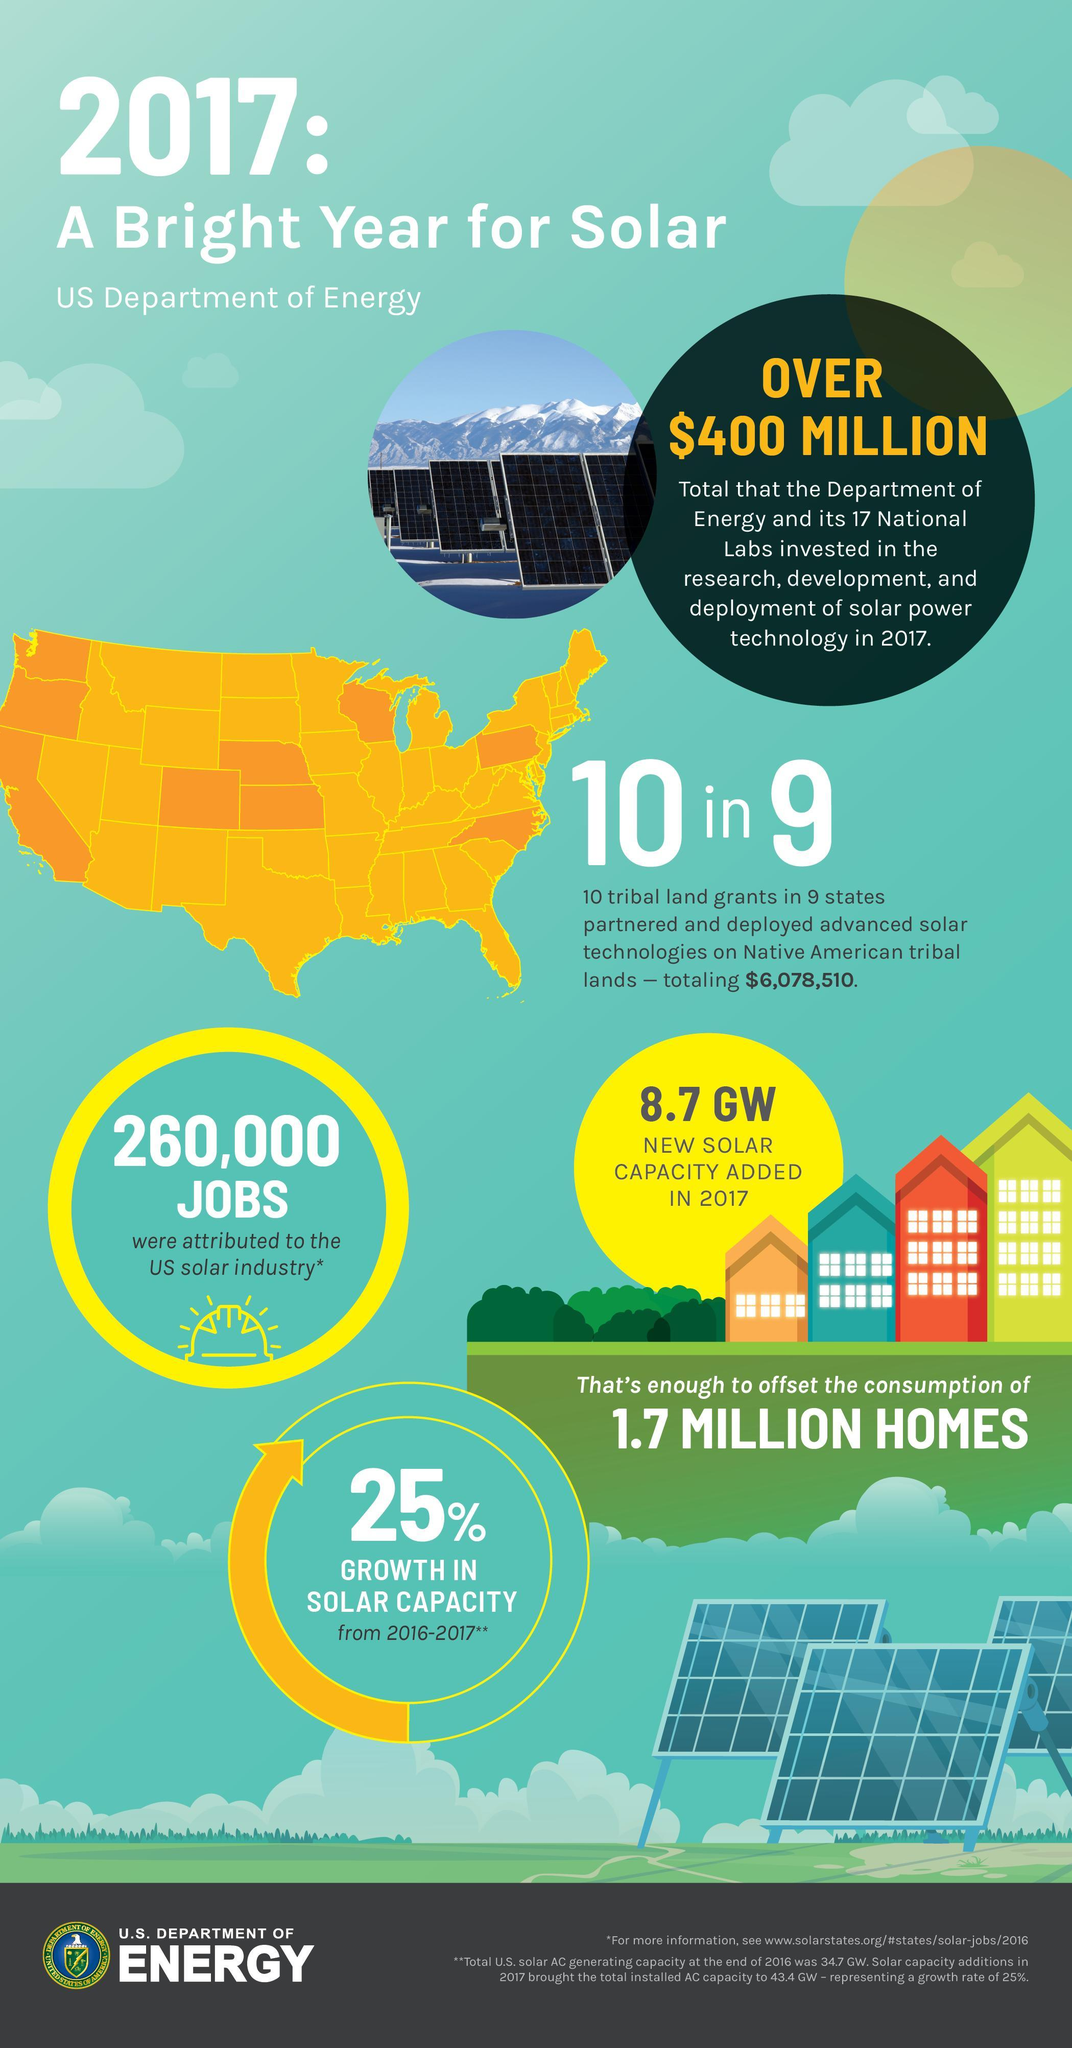What is the solar power added to offset the consumption of 1.7 million homes in the U.S. in 2017?
Answer the question with a short phrase. 8.7 GW What is the no of jobs attributed to the US solar industry in 2017? 260,000 What is the percentage of growth in solar capacity from 2016-2017 in the U.S.? 25% 